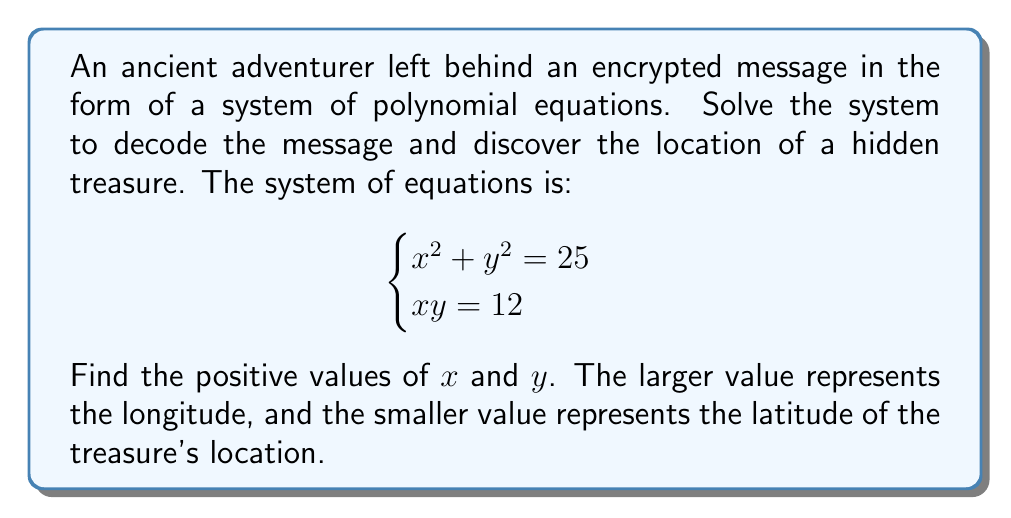Could you help me with this problem? Let's solve this system of polynomial equations step by step:

1) We have two equations:
   $$x^2 + y^2 = 25$$ (Equation 1)
   $$xy = 12$$ (Equation 2)

2) From Equation 2, we can express $y$ in terms of $x$:
   $$y = \frac{12}{x}$$

3) Substitute this into Equation 1:
   $$x^2 + (\frac{12}{x})^2 = 25$$

4) Multiply both sides by $x^2$:
   $$x^4 + 144 = 25x^2$$

5) Rearrange the equation:
   $$x^4 - 25x^2 + 144 = 0$$

6) This is a quadratic equation in $x^2$. Let $u = x^2$:
   $$u^2 - 25u + 144 = 0$$

7) Solve this quadratic equation using the quadratic formula:
   $$u = \frac{25 \pm \sqrt{25^2 - 4(1)(144)}}{2(1)}$$
   $$u = \frac{25 \pm \sqrt{625 - 576}}{2} = \frac{25 \pm 7}{2}$$

8) Therefore, $u = 16$ or $u = 9$

9) Since $u = x^2$, we have:
   $x = \pm 4$ or $x = \pm 3$

10) We're only interested in positive values, so $x = 4$ or $x = 3$

11) From Equation 2, if $x = 4$, then $y = 3$, and if $x = 3$, then $y = 4$

Therefore, the positive solutions are $(x, y) = (4, 3)$ or $(3, 4)$. The larger value is 4, representing the longitude, and the smaller value is 3, representing the latitude.
Answer: Longitude: 4, Latitude: 3 